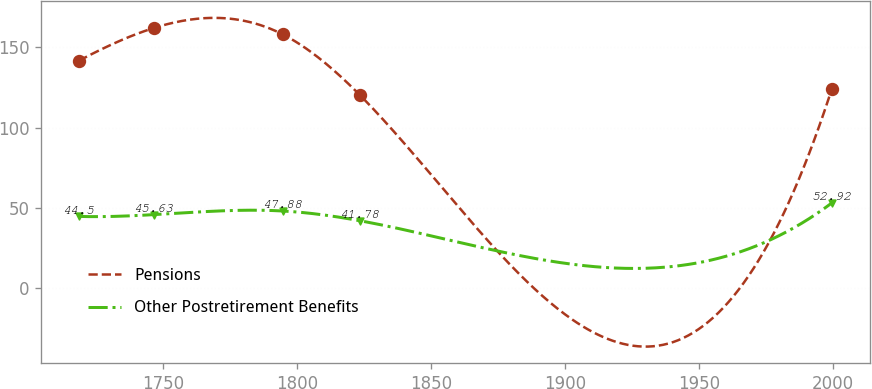Convert chart. <chart><loc_0><loc_0><loc_500><loc_500><line_chart><ecel><fcel>Pensions<fcel>Other Postretirement Benefits<nl><fcel>1718.39<fcel>141.68<fcel>44.5<nl><fcel>1746.5<fcel>162.19<fcel>45.63<nl><fcel>1794.55<fcel>158.13<fcel>47.88<nl><fcel>1823.42<fcel>120.1<fcel>41.78<nl><fcel>1999.49<fcel>124.16<fcel>52.92<nl></chart> 